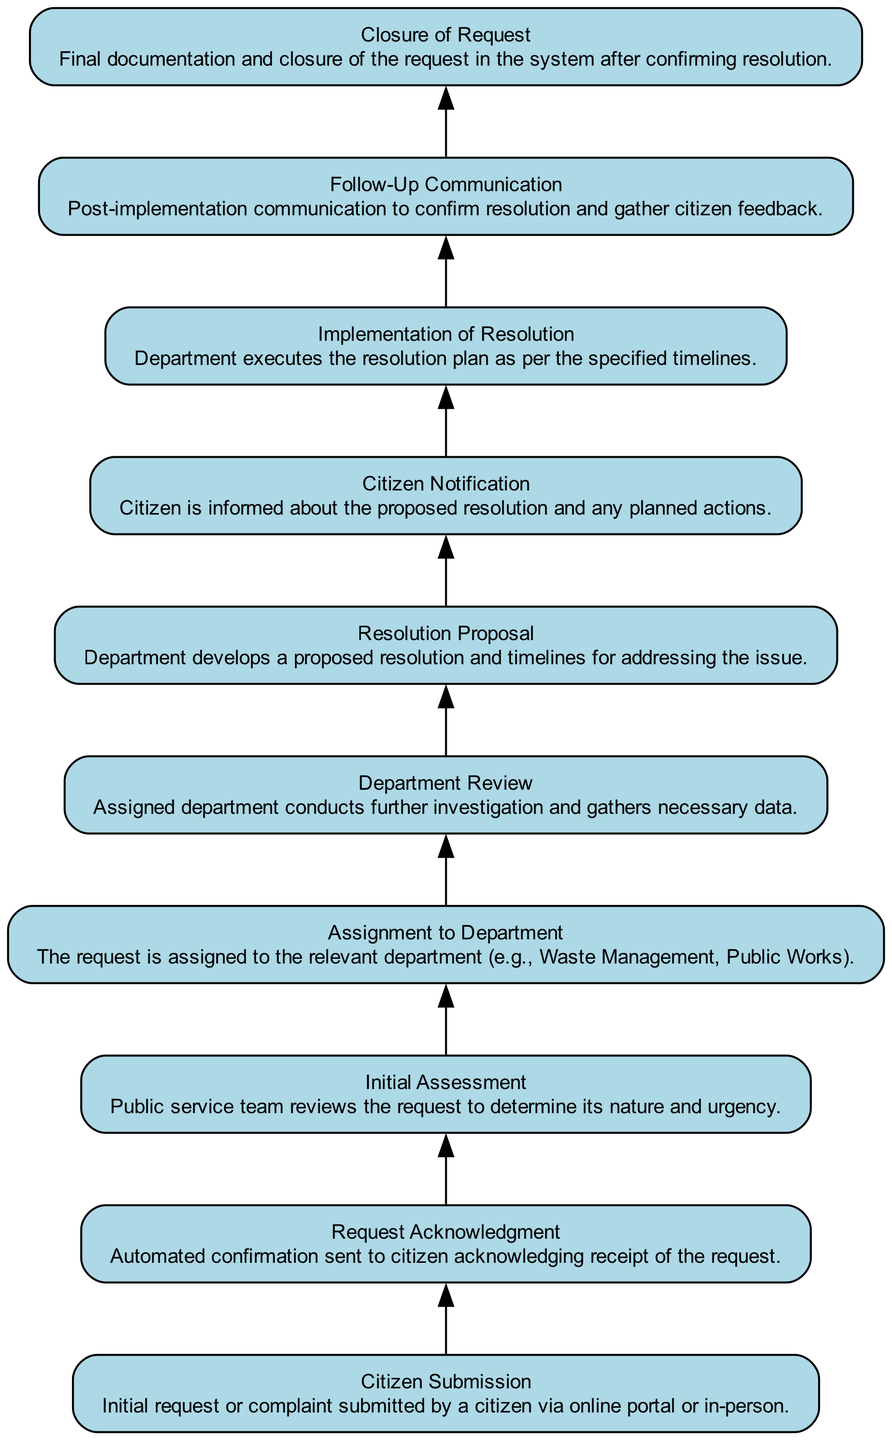What is the first step in the citizen service request pathway? The first step listed in the diagram is "Citizen Submission," which is the initial request or complaint submitted by a citizen.
Answer: Citizen Submission How many nodes are there in the diagram? By counting the elements listed in the diagram, there are a total of ten nodes.
Answer: 10 What does the "Request Acknowledgment" node represent? The "Request Acknowledgment" node represents the process where an automated confirmation is sent to the citizen acknowledging receipt of the request.
Answer: Automated confirmation Which node comes after "Initial Assessment"? Following the "Initial Assessment" node, the next node is "Assignment to Department."
Answer: Assignment to Department How many connections does the "Department Review" node have? The "Department Review" node has one connection leading to it from the "Assignment to Department" node.
Answer: 1 What action occurs immediately after "Citizen Notification"? The action that occurs immediately after "Citizen Notification" is the "Implementation of Resolution."
Answer: Implementation of Resolution Which two nodes define the resolution proposal and citizen notification process? The two nodes that define this process are "Resolution Proposal" and "Citizen Notification" as they outline the development of the proposal and the communication to the citizen.
Answer: Resolution Proposal and Citizen Notification What is the purpose of the "Follow-Up Communication" node? The purpose of the "Follow-Up Communication" node is to provide post-implementation communication to confirm resolution and gather citizen feedback.
Answer: Confirm resolution and gather feedback Identify the node that indicates the final step of the process. The final step of the process is indicated by the "Closure of Request" node, which represents final documentation and closing the request in the system.
Answer: Closure of Request 